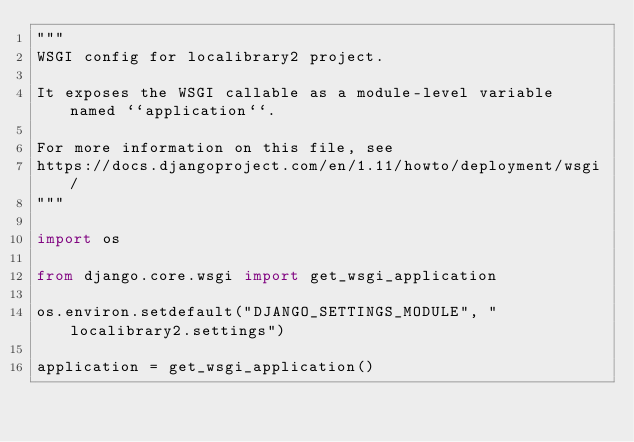Convert code to text. <code><loc_0><loc_0><loc_500><loc_500><_Python_>"""
WSGI config for localibrary2 project.

It exposes the WSGI callable as a module-level variable named ``application``.

For more information on this file, see
https://docs.djangoproject.com/en/1.11/howto/deployment/wsgi/
"""

import os

from django.core.wsgi import get_wsgi_application

os.environ.setdefault("DJANGO_SETTINGS_MODULE", "localibrary2.settings")

application = get_wsgi_application()
</code> 